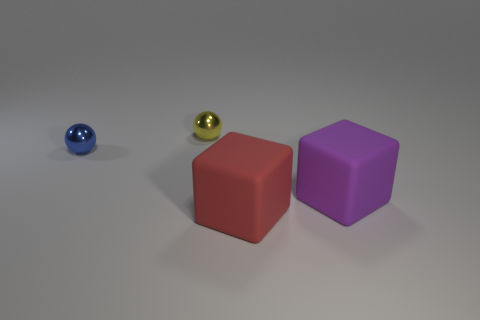What color is the thing that is made of the same material as the blue ball?
Your answer should be compact. Yellow. What number of gray objects are tiny metal spheres or matte cubes?
Give a very brief answer. 0. Is the number of big cyan matte things greater than the number of small spheres?
Provide a succinct answer. No. How many objects are balls that are on the right side of the small blue thing or small yellow spheres on the left side of the red object?
Provide a short and direct response. 1. There is a metal thing that is the same size as the blue ball; what is its color?
Make the answer very short. Yellow. Does the blue thing have the same material as the purple block?
Your answer should be compact. No. There is a tiny blue sphere that is behind the big matte thing behind the large red object; what is it made of?
Offer a terse response. Metal. Is the number of balls that are left of the tiny yellow thing greater than the number of purple rubber cylinders?
Offer a very short reply. Yes. What number of other things are the same size as the blue object?
Provide a succinct answer. 1. What color is the small metal ball that is on the right side of the metallic object in front of the ball behind the blue shiny thing?
Offer a very short reply. Yellow. 